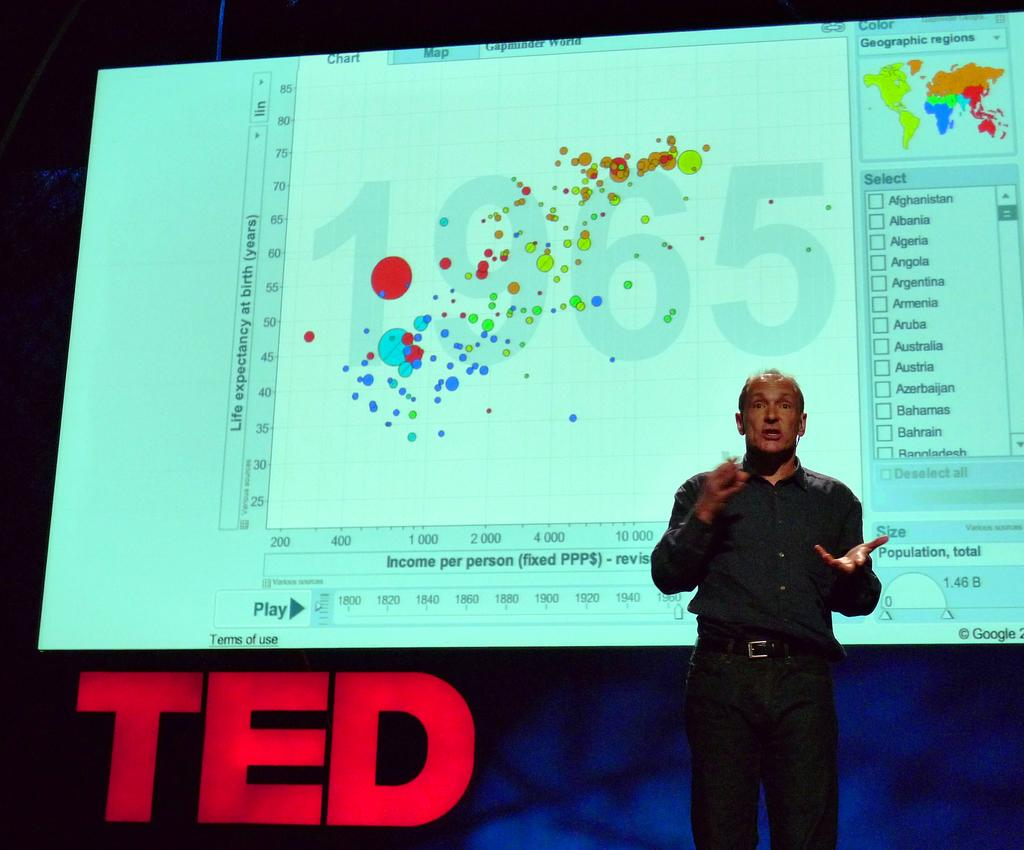What is the main subject of the image? There is a person in the image. Can you describe the background of the image? There is a screen visible in the background of the image. What type of disgust can be seen on the person's face in the image? There is no indication of disgust on the person's face in the image. What type of guitar is being played by the person in the image? There is no guitar present in the image; the person is not playing any musical instrument. 